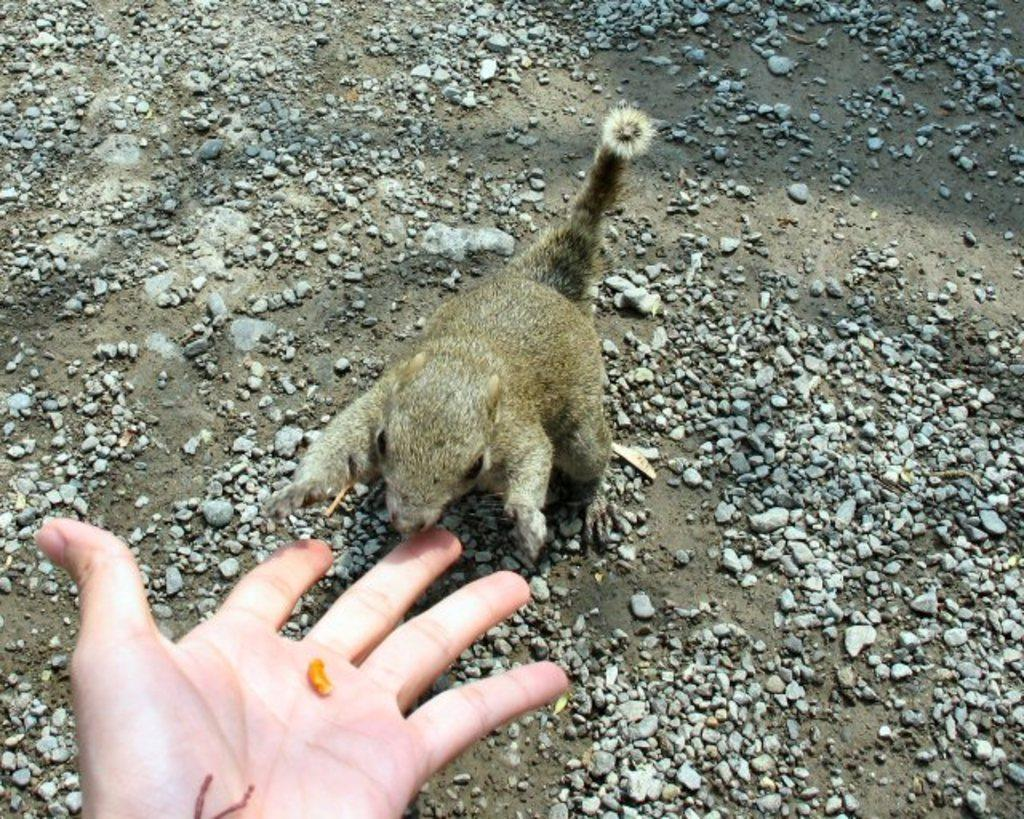What type of animal can be seen in the image? There is a squirrel in the image. What is the human hand holding in the image? There is a nut in the hand. What can be found on the ground in the image? Small stones are visible on the ground in the image. What type of calculator is the squirrel using in the image? There is no calculator present in the image; it features a squirrel and a human hand holding a nut. 